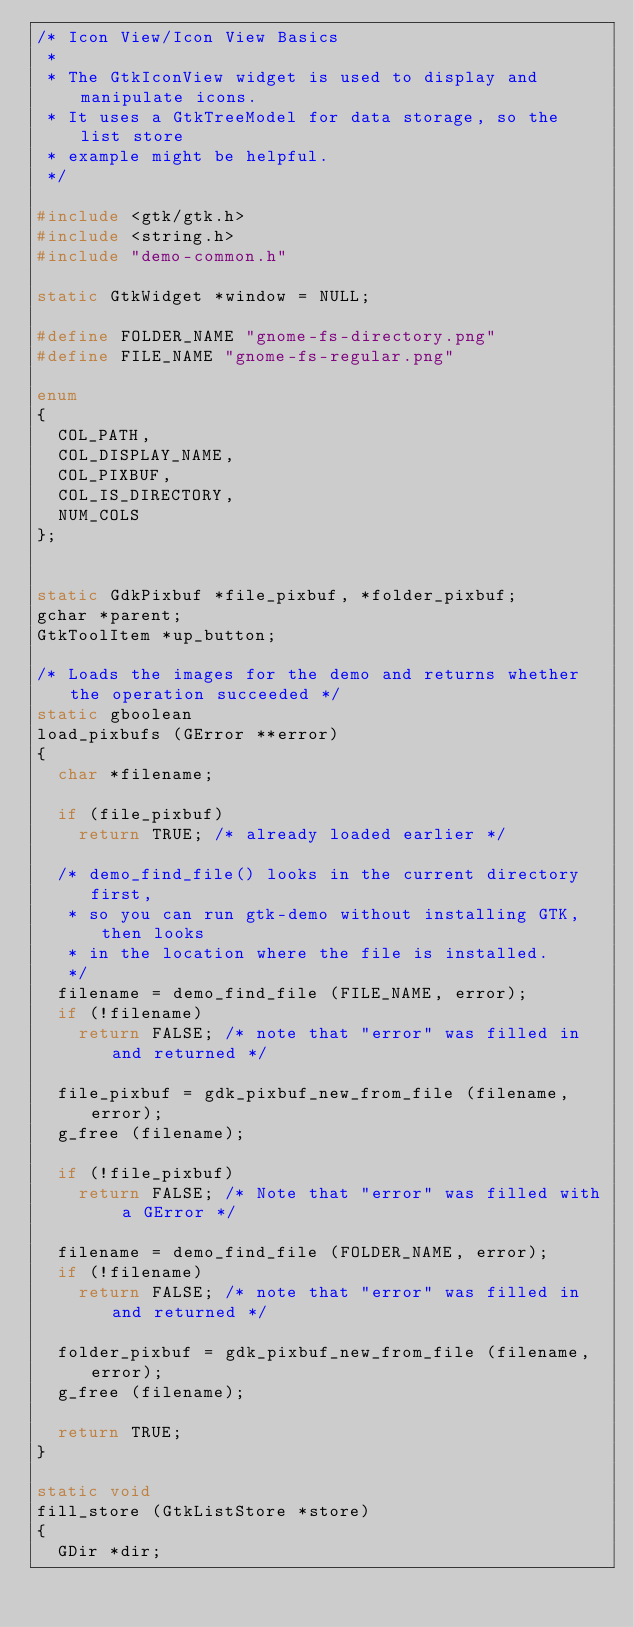Convert code to text. <code><loc_0><loc_0><loc_500><loc_500><_C_>/* Icon View/Icon View Basics
 *
 * The GtkIconView widget is used to display and manipulate icons.
 * It uses a GtkTreeModel for data storage, so the list store
 * example might be helpful.
 */

#include <gtk/gtk.h>
#include <string.h>
#include "demo-common.h"

static GtkWidget *window = NULL;

#define FOLDER_NAME "gnome-fs-directory.png"
#define FILE_NAME "gnome-fs-regular.png"

enum
{
  COL_PATH,
  COL_DISPLAY_NAME,
  COL_PIXBUF,
  COL_IS_DIRECTORY,
  NUM_COLS
};


static GdkPixbuf *file_pixbuf, *folder_pixbuf;
gchar *parent;
GtkToolItem *up_button;

/* Loads the images for the demo and returns whether the operation succeeded */
static gboolean
load_pixbufs (GError **error)
{
  char *filename;

  if (file_pixbuf)
    return TRUE; /* already loaded earlier */

  /* demo_find_file() looks in the current directory first,
   * so you can run gtk-demo without installing GTK, then looks
   * in the location where the file is installed.
   */
  filename = demo_find_file (FILE_NAME, error);
  if (!filename)
    return FALSE; /* note that "error" was filled in and returned */

  file_pixbuf = gdk_pixbuf_new_from_file (filename, error);
  g_free (filename);

  if (!file_pixbuf)
    return FALSE; /* Note that "error" was filled with a GError */

  filename = demo_find_file (FOLDER_NAME, error);
  if (!filename)
    return FALSE; /* note that "error" was filled in and returned */

  folder_pixbuf = gdk_pixbuf_new_from_file (filename, error);
  g_free (filename);

  return TRUE;
}

static void
fill_store (GtkListStore *store)
{
  GDir *dir;</code> 